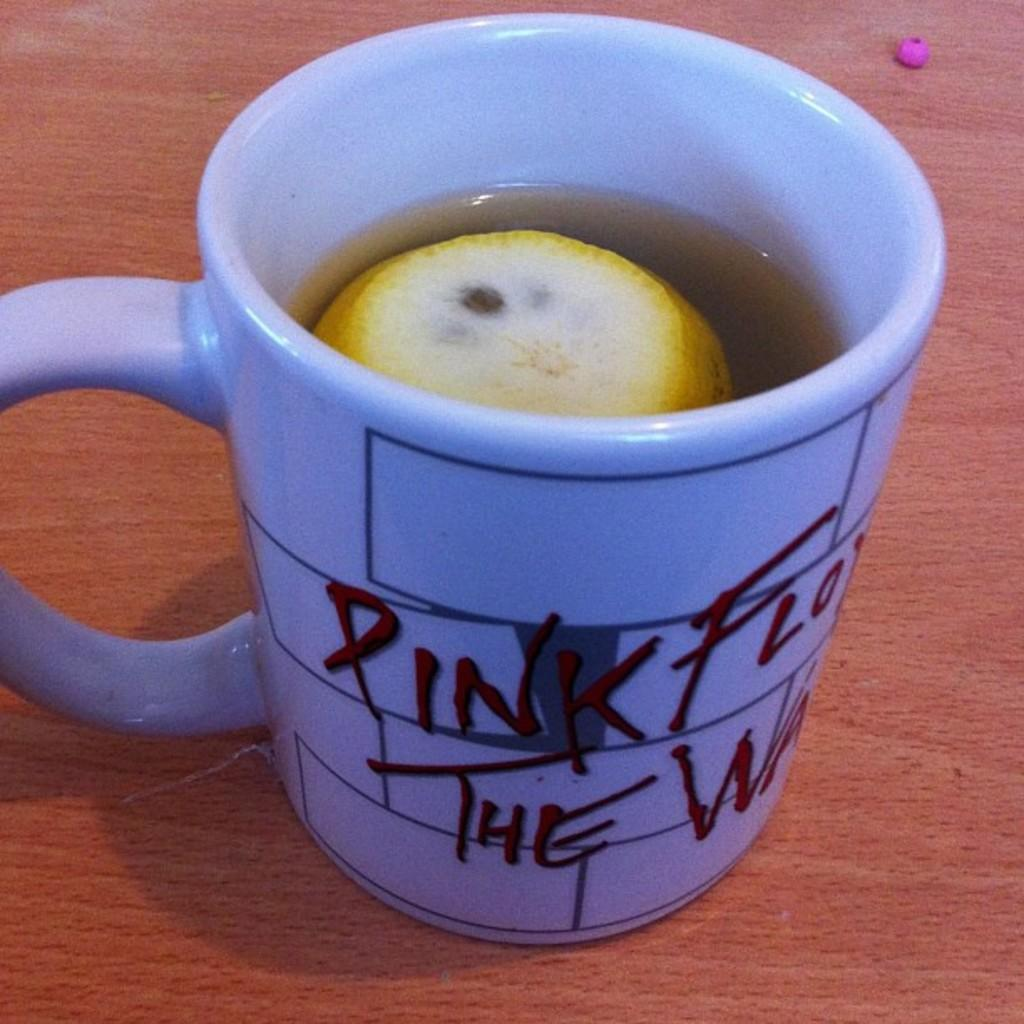<image>
Write a terse but informative summary of the picture. a coffee mug that says pink flow and lemon in it 